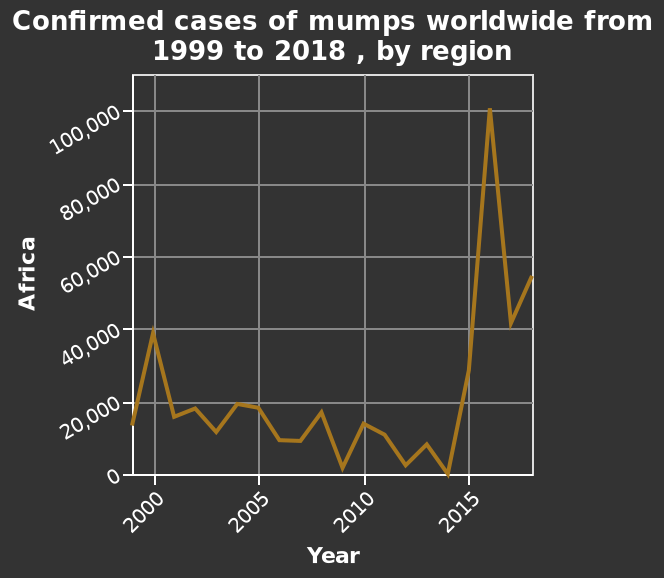<image>
Offer a thorough analysis of the image. In 2014 there was a sharp increase in African cases of the mumps. What does the line plot show about the cases of mumps in Africa? The line plot shows the number of confirmed cases of mumps in Africa over time, with the y-axis representing the range of 0 to 100,000 and the x-axis representing the years from 2000 to 2015. How is Africa represented on the line plot? Africa is represented on the line plot with a linear scale of range 0 to 100,000 along the y-axis. 